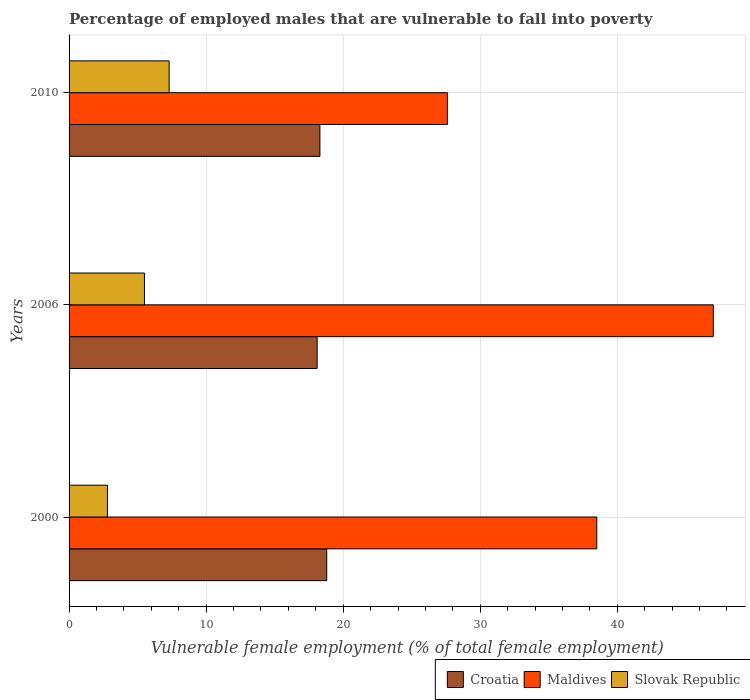How many different coloured bars are there?
Your answer should be compact. 3. How many groups of bars are there?
Provide a succinct answer. 3. Are the number of bars on each tick of the Y-axis equal?
Offer a terse response. Yes. What is the label of the 3rd group of bars from the top?
Make the answer very short. 2000. What is the percentage of employed males who are vulnerable to fall into poverty in Maldives in 2010?
Your answer should be compact. 27.6. Across all years, what is the maximum percentage of employed males who are vulnerable to fall into poverty in Maldives?
Your answer should be compact. 47. Across all years, what is the minimum percentage of employed males who are vulnerable to fall into poverty in Croatia?
Provide a short and direct response. 18.1. In which year was the percentage of employed males who are vulnerable to fall into poverty in Slovak Republic maximum?
Offer a terse response. 2010. In which year was the percentage of employed males who are vulnerable to fall into poverty in Slovak Republic minimum?
Offer a terse response. 2000. What is the total percentage of employed males who are vulnerable to fall into poverty in Slovak Republic in the graph?
Offer a terse response. 15.6. What is the difference between the percentage of employed males who are vulnerable to fall into poverty in Slovak Republic in 2000 and that in 2006?
Keep it short and to the point. -2.7. What is the difference between the percentage of employed males who are vulnerable to fall into poverty in Maldives in 2006 and the percentage of employed males who are vulnerable to fall into poverty in Slovak Republic in 2000?
Make the answer very short. 44.2. What is the average percentage of employed males who are vulnerable to fall into poverty in Croatia per year?
Your answer should be compact. 18.4. In the year 2000, what is the difference between the percentage of employed males who are vulnerable to fall into poverty in Croatia and percentage of employed males who are vulnerable to fall into poverty in Maldives?
Give a very brief answer. -19.7. What is the ratio of the percentage of employed males who are vulnerable to fall into poverty in Croatia in 2000 to that in 2006?
Keep it short and to the point. 1.04. What is the difference between the highest and the second highest percentage of employed males who are vulnerable to fall into poverty in Croatia?
Make the answer very short. 0.5. What is the difference between the highest and the lowest percentage of employed males who are vulnerable to fall into poverty in Maldives?
Your answer should be very brief. 19.4. In how many years, is the percentage of employed males who are vulnerable to fall into poverty in Maldives greater than the average percentage of employed males who are vulnerable to fall into poverty in Maldives taken over all years?
Your answer should be very brief. 2. Is the sum of the percentage of employed males who are vulnerable to fall into poverty in Maldives in 2000 and 2006 greater than the maximum percentage of employed males who are vulnerable to fall into poverty in Croatia across all years?
Your response must be concise. Yes. What does the 3rd bar from the top in 2000 represents?
Your answer should be very brief. Croatia. What does the 3rd bar from the bottom in 2000 represents?
Your answer should be compact. Slovak Republic. Is it the case that in every year, the sum of the percentage of employed males who are vulnerable to fall into poverty in Slovak Republic and percentage of employed males who are vulnerable to fall into poverty in Maldives is greater than the percentage of employed males who are vulnerable to fall into poverty in Croatia?
Your answer should be very brief. Yes. How many bars are there?
Your response must be concise. 9. What is the difference between two consecutive major ticks on the X-axis?
Offer a terse response. 10. Does the graph contain grids?
Provide a short and direct response. Yes. Where does the legend appear in the graph?
Your response must be concise. Bottom right. What is the title of the graph?
Your answer should be very brief. Percentage of employed males that are vulnerable to fall into poverty. Does "New Caledonia" appear as one of the legend labels in the graph?
Your answer should be compact. No. What is the label or title of the X-axis?
Make the answer very short. Vulnerable female employment (% of total female employment). What is the Vulnerable female employment (% of total female employment) of Croatia in 2000?
Keep it short and to the point. 18.8. What is the Vulnerable female employment (% of total female employment) in Maldives in 2000?
Provide a succinct answer. 38.5. What is the Vulnerable female employment (% of total female employment) in Slovak Republic in 2000?
Your answer should be very brief. 2.8. What is the Vulnerable female employment (% of total female employment) of Croatia in 2006?
Keep it short and to the point. 18.1. What is the Vulnerable female employment (% of total female employment) in Croatia in 2010?
Your response must be concise. 18.3. What is the Vulnerable female employment (% of total female employment) in Maldives in 2010?
Ensure brevity in your answer.  27.6. What is the Vulnerable female employment (% of total female employment) in Slovak Republic in 2010?
Your response must be concise. 7.3. Across all years, what is the maximum Vulnerable female employment (% of total female employment) in Croatia?
Your answer should be very brief. 18.8. Across all years, what is the maximum Vulnerable female employment (% of total female employment) of Maldives?
Provide a short and direct response. 47. Across all years, what is the maximum Vulnerable female employment (% of total female employment) of Slovak Republic?
Make the answer very short. 7.3. Across all years, what is the minimum Vulnerable female employment (% of total female employment) of Croatia?
Your answer should be very brief. 18.1. Across all years, what is the minimum Vulnerable female employment (% of total female employment) in Maldives?
Keep it short and to the point. 27.6. Across all years, what is the minimum Vulnerable female employment (% of total female employment) of Slovak Republic?
Provide a succinct answer. 2.8. What is the total Vulnerable female employment (% of total female employment) of Croatia in the graph?
Give a very brief answer. 55.2. What is the total Vulnerable female employment (% of total female employment) of Maldives in the graph?
Provide a succinct answer. 113.1. What is the total Vulnerable female employment (% of total female employment) of Slovak Republic in the graph?
Give a very brief answer. 15.6. What is the difference between the Vulnerable female employment (% of total female employment) in Maldives in 2000 and that in 2006?
Offer a very short reply. -8.5. What is the difference between the Vulnerable female employment (% of total female employment) in Slovak Republic in 2000 and that in 2006?
Keep it short and to the point. -2.7. What is the difference between the Vulnerable female employment (% of total female employment) of Maldives in 2006 and that in 2010?
Offer a very short reply. 19.4. What is the difference between the Vulnerable female employment (% of total female employment) of Croatia in 2000 and the Vulnerable female employment (% of total female employment) of Maldives in 2006?
Your response must be concise. -28.2. What is the difference between the Vulnerable female employment (% of total female employment) in Croatia in 2000 and the Vulnerable female employment (% of total female employment) in Slovak Republic in 2010?
Ensure brevity in your answer.  11.5. What is the difference between the Vulnerable female employment (% of total female employment) of Maldives in 2000 and the Vulnerable female employment (% of total female employment) of Slovak Republic in 2010?
Provide a succinct answer. 31.2. What is the difference between the Vulnerable female employment (% of total female employment) of Maldives in 2006 and the Vulnerable female employment (% of total female employment) of Slovak Republic in 2010?
Provide a succinct answer. 39.7. What is the average Vulnerable female employment (% of total female employment) of Croatia per year?
Provide a succinct answer. 18.4. What is the average Vulnerable female employment (% of total female employment) in Maldives per year?
Your answer should be compact. 37.7. What is the average Vulnerable female employment (% of total female employment) of Slovak Republic per year?
Offer a terse response. 5.2. In the year 2000, what is the difference between the Vulnerable female employment (% of total female employment) of Croatia and Vulnerable female employment (% of total female employment) of Maldives?
Make the answer very short. -19.7. In the year 2000, what is the difference between the Vulnerable female employment (% of total female employment) in Maldives and Vulnerable female employment (% of total female employment) in Slovak Republic?
Ensure brevity in your answer.  35.7. In the year 2006, what is the difference between the Vulnerable female employment (% of total female employment) in Croatia and Vulnerable female employment (% of total female employment) in Maldives?
Offer a terse response. -28.9. In the year 2006, what is the difference between the Vulnerable female employment (% of total female employment) of Maldives and Vulnerable female employment (% of total female employment) of Slovak Republic?
Your answer should be compact. 41.5. In the year 2010, what is the difference between the Vulnerable female employment (% of total female employment) of Croatia and Vulnerable female employment (% of total female employment) of Slovak Republic?
Give a very brief answer. 11. In the year 2010, what is the difference between the Vulnerable female employment (% of total female employment) of Maldives and Vulnerable female employment (% of total female employment) of Slovak Republic?
Ensure brevity in your answer.  20.3. What is the ratio of the Vulnerable female employment (% of total female employment) of Croatia in 2000 to that in 2006?
Provide a succinct answer. 1.04. What is the ratio of the Vulnerable female employment (% of total female employment) of Maldives in 2000 to that in 2006?
Your response must be concise. 0.82. What is the ratio of the Vulnerable female employment (% of total female employment) in Slovak Republic in 2000 to that in 2006?
Your answer should be very brief. 0.51. What is the ratio of the Vulnerable female employment (% of total female employment) of Croatia in 2000 to that in 2010?
Make the answer very short. 1.03. What is the ratio of the Vulnerable female employment (% of total female employment) of Maldives in 2000 to that in 2010?
Your response must be concise. 1.39. What is the ratio of the Vulnerable female employment (% of total female employment) of Slovak Republic in 2000 to that in 2010?
Offer a very short reply. 0.38. What is the ratio of the Vulnerable female employment (% of total female employment) in Maldives in 2006 to that in 2010?
Offer a very short reply. 1.7. What is the ratio of the Vulnerable female employment (% of total female employment) in Slovak Republic in 2006 to that in 2010?
Make the answer very short. 0.75. What is the difference between the highest and the second highest Vulnerable female employment (% of total female employment) in Croatia?
Give a very brief answer. 0.5. What is the difference between the highest and the second highest Vulnerable female employment (% of total female employment) in Maldives?
Provide a short and direct response. 8.5. 